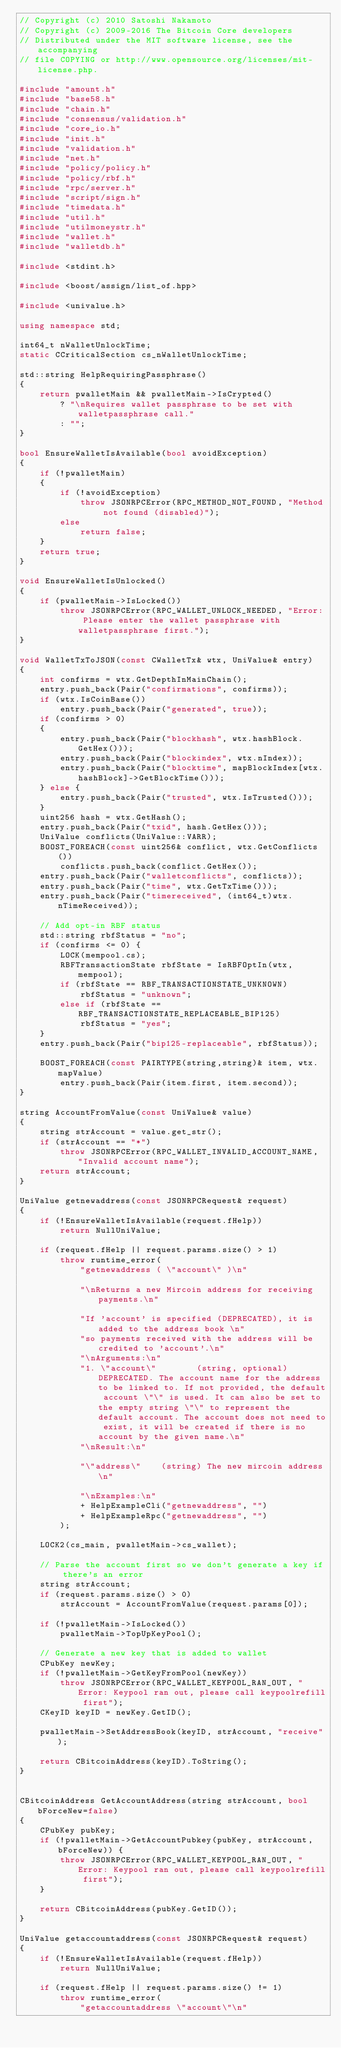<code> <loc_0><loc_0><loc_500><loc_500><_C++_>// Copyright (c) 2010 Satoshi Nakamoto
// Copyright (c) 2009-2016 The Bitcoin Core developers
// Distributed under the MIT software license, see the accompanying
// file COPYING or http://www.opensource.org/licenses/mit-license.php.

#include "amount.h"
#include "base58.h"
#include "chain.h"
#include "consensus/validation.h"
#include "core_io.h"
#include "init.h"
#include "validation.h"
#include "net.h"
#include "policy/policy.h"
#include "policy/rbf.h"
#include "rpc/server.h"
#include "script/sign.h"
#include "timedata.h"
#include "util.h"
#include "utilmoneystr.h"
#include "wallet.h"
#include "walletdb.h"

#include <stdint.h>

#include <boost/assign/list_of.hpp>

#include <univalue.h>

using namespace std;

int64_t nWalletUnlockTime;
static CCriticalSection cs_nWalletUnlockTime;

std::string HelpRequiringPassphrase()
{
    return pwalletMain && pwalletMain->IsCrypted()
        ? "\nRequires wallet passphrase to be set with walletpassphrase call."
        : "";
}

bool EnsureWalletIsAvailable(bool avoidException)
{
    if (!pwalletMain)
    {
        if (!avoidException)
            throw JSONRPCError(RPC_METHOD_NOT_FOUND, "Method not found (disabled)");
        else
            return false;
    }
    return true;
}

void EnsureWalletIsUnlocked()
{
    if (pwalletMain->IsLocked())
        throw JSONRPCError(RPC_WALLET_UNLOCK_NEEDED, "Error: Please enter the wallet passphrase with walletpassphrase first.");
}

void WalletTxToJSON(const CWalletTx& wtx, UniValue& entry)
{
    int confirms = wtx.GetDepthInMainChain();
    entry.push_back(Pair("confirmations", confirms));
    if (wtx.IsCoinBase())
        entry.push_back(Pair("generated", true));
    if (confirms > 0)
    {
        entry.push_back(Pair("blockhash", wtx.hashBlock.GetHex()));
        entry.push_back(Pair("blockindex", wtx.nIndex));
        entry.push_back(Pair("blocktime", mapBlockIndex[wtx.hashBlock]->GetBlockTime()));
    } else {
        entry.push_back(Pair("trusted", wtx.IsTrusted()));
    }
    uint256 hash = wtx.GetHash();
    entry.push_back(Pair("txid", hash.GetHex()));
    UniValue conflicts(UniValue::VARR);
    BOOST_FOREACH(const uint256& conflict, wtx.GetConflicts())
        conflicts.push_back(conflict.GetHex());
    entry.push_back(Pair("walletconflicts", conflicts));
    entry.push_back(Pair("time", wtx.GetTxTime()));
    entry.push_back(Pair("timereceived", (int64_t)wtx.nTimeReceived));

    // Add opt-in RBF status
    std::string rbfStatus = "no";
    if (confirms <= 0) {
        LOCK(mempool.cs);
        RBFTransactionState rbfState = IsRBFOptIn(wtx, mempool);
        if (rbfState == RBF_TRANSACTIONSTATE_UNKNOWN)
            rbfStatus = "unknown";
        else if (rbfState == RBF_TRANSACTIONSTATE_REPLACEABLE_BIP125)
            rbfStatus = "yes";
    }
    entry.push_back(Pair("bip125-replaceable", rbfStatus));

    BOOST_FOREACH(const PAIRTYPE(string,string)& item, wtx.mapValue)
        entry.push_back(Pair(item.first, item.second));
}

string AccountFromValue(const UniValue& value)
{
    string strAccount = value.get_str();
    if (strAccount == "*")
        throw JSONRPCError(RPC_WALLET_INVALID_ACCOUNT_NAME, "Invalid account name");
    return strAccount;
}

UniValue getnewaddress(const JSONRPCRequest& request)
{
    if (!EnsureWalletIsAvailable(request.fHelp))
        return NullUniValue;

    if (request.fHelp || request.params.size() > 1)
        throw runtime_error(
            "getnewaddress ( \"account\" )\n"

            "\nReturns a new Mircoin address for receiving payments.\n"

            "If 'account' is specified (DEPRECATED), it is added to the address book \n"
            "so payments received with the address will be credited to 'account'.\n"
            "\nArguments:\n"
            "1. \"account\"        (string, optional) DEPRECATED. The account name for the address to be linked to. If not provided, the default account \"\" is used. It can also be set to the empty string \"\" to represent the default account. The account does not need to exist, it will be created if there is no account by the given name.\n"
            "\nResult:\n"

            "\"address\"    (string) The new mircoin address\n"

            "\nExamples:\n"
            + HelpExampleCli("getnewaddress", "")
            + HelpExampleRpc("getnewaddress", "")
        );

    LOCK2(cs_main, pwalletMain->cs_wallet);

    // Parse the account first so we don't generate a key if there's an error
    string strAccount;
    if (request.params.size() > 0)
        strAccount = AccountFromValue(request.params[0]);

    if (!pwalletMain->IsLocked())
        pwalletMain->TopUpKeyPool();

    // Generate a new key that is added to wallet
    CPubKey newKey;
    if (!pwalletMain->GetKeyFromPool(newKey))
        throw JSONRPCError(RPC_WALLET_KEYPOOL_RAN_OUT, "Error: Keypool ran out, please call keypoolrefill first");
    CKeyID keyID = newKey.GetID();

    pwalletMain->SetAddressBook(keyID, strAccount, "receive");

    return CBitcoinAddress(keyID).ToString();
}


CBitcoinAddress GetAccountAddress(string strAccount, bool bForceNew=false)
{
    CPubKey pubKey;
    if (!pwalletMain->GetAccountPubkey(pubKey, strAccount, bForceNew)) {
        throw JSONRPCError(RPC_WALLET_KEYPOOL_RAN_OUT, "Error: Keypool ran out, please call keypoolrefill first");
    }

    return CBitcoinAddress(pubKey.GetID());
}

UniValue getaccountaddress(const JSONRPCRequest& request)
{
    if (!EnsureWalletIsAvailable(request.fHelp))
        return NullUniValue;

    if (request.fHelp || request.params.size() != 1)
        throw runtime_error(
            "getaccountaddress \"account\"\n"
</code> 